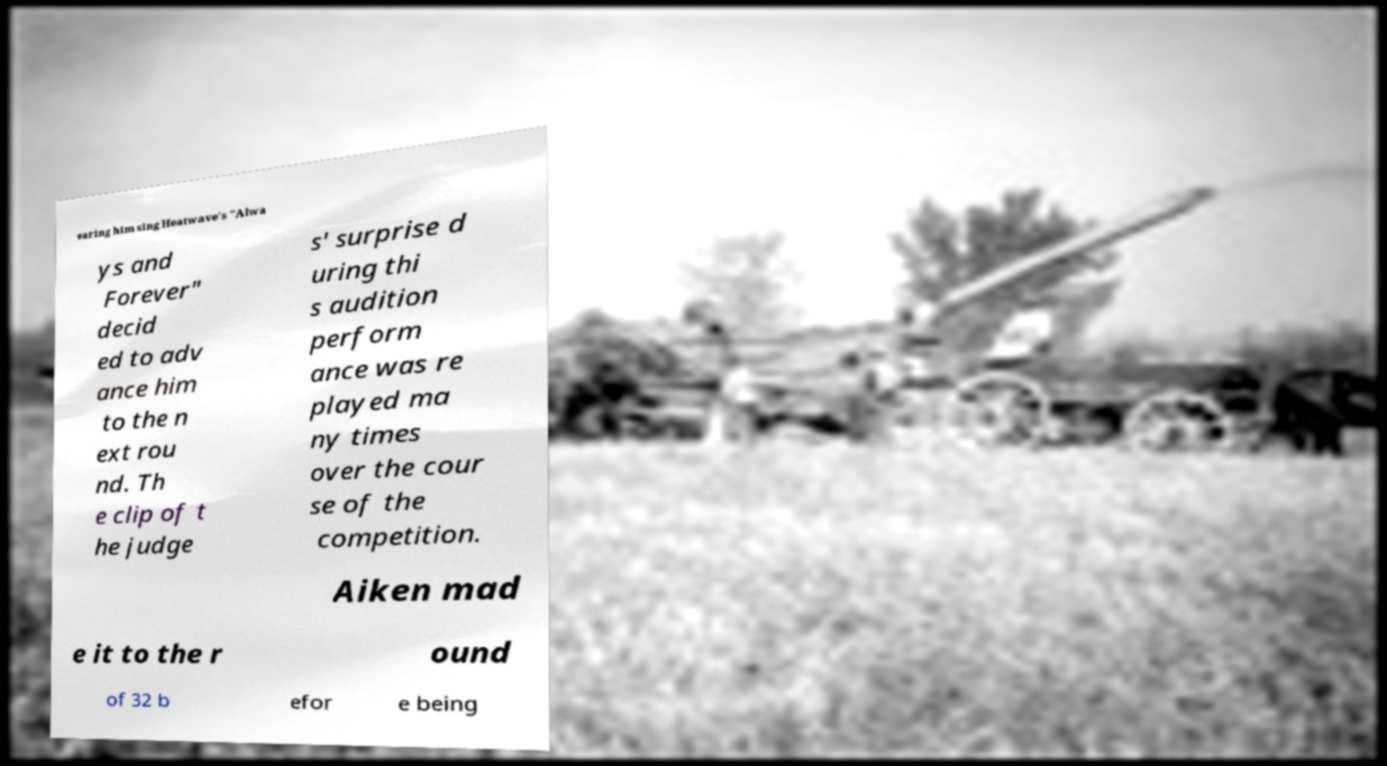Could you assist in decoding the text presented in this image and type it out clearly? earing him sing Heatwave's "Alwa ys and Forever" decid ed to adv ance him to the n ext rou nd. Th e clip of t he judge s' surprise d uring thi s audition perform ance was re played ma ny times over the cour se of the competition. Aiken mad e it to the r ound of 32 b efor e being 